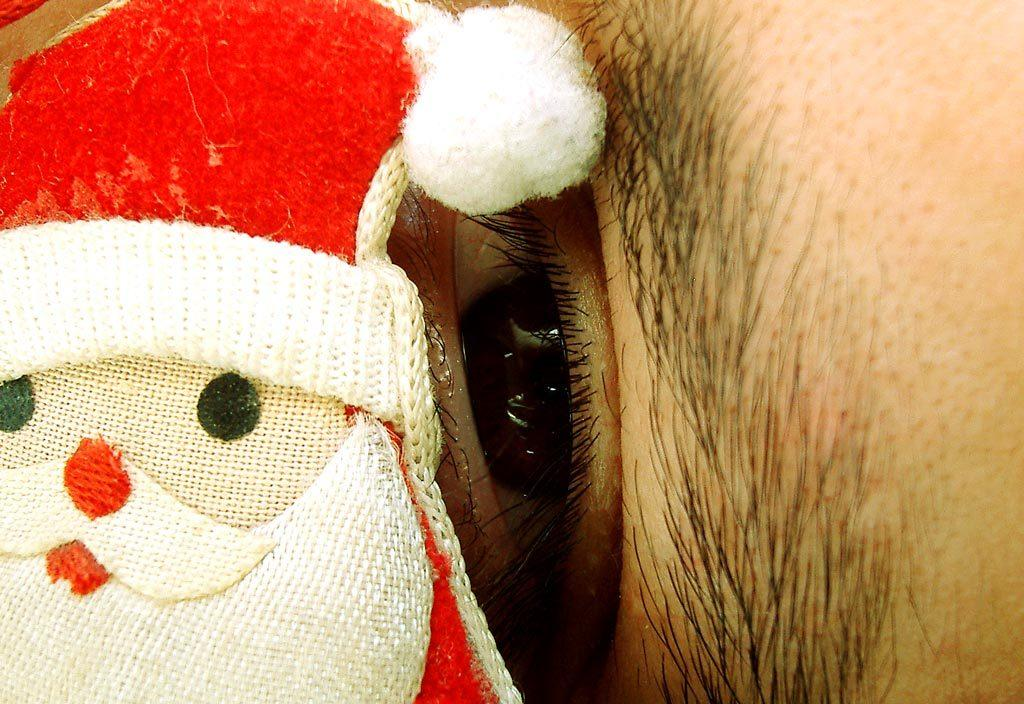What is the main subject of the image? There is a doll in the image. Can you describe any other elements in the image? There is a person's eye visible in the background of the image. What theory does the brother of the artist have about the canvas in the image? There is no canvas or artist mentioned in the image, and no brother is present. 